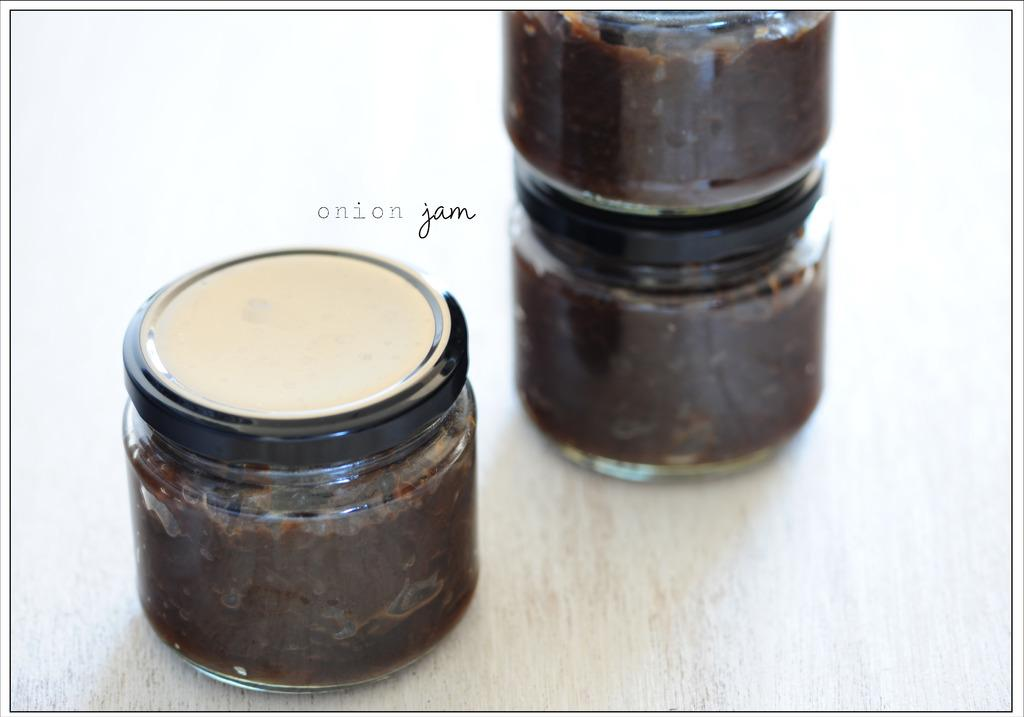<image>
Present a compact description of the photo's key features. Several jars of onion jam are on a table. 